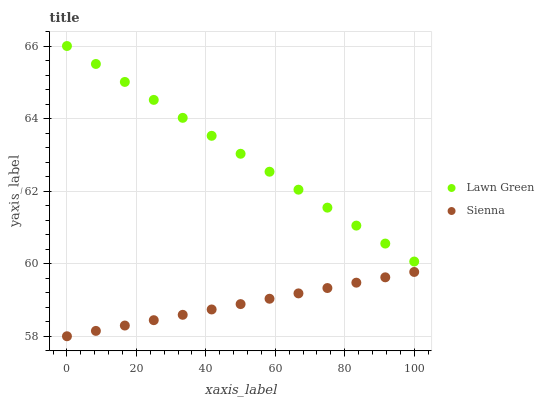Does Sienna have the minimum area under the curve?
Answer yes or no. Yes. Does Lawn Green have the maximum area under the curve?
Answer yes or no. Yes. Does Lawn Green have the minimum area under the curve?
Answer yes or no. No. Is Sienna the smoothest?
Answer yes or no. Yes. Is Lawn Green the roughest?
Answer yes or no. Yes. Is Lawn Green the smoothest?
Answer yes or no. No. Does Sienna have the lowest value?
Answer yes or no. Yes. Does Lawn Green have the lowest value?
Answer yes or no. No. Does Lawn Green have the highest value?
Answer yes or no. Yes. Is Sienna less than Lawn Green?
Answer yes or no. Yes. Is Lawn Green greater than Sienna?
Answer yes or no. Yes. Does Sienna intersect Lawn Green?
Answer yes or no. No. 